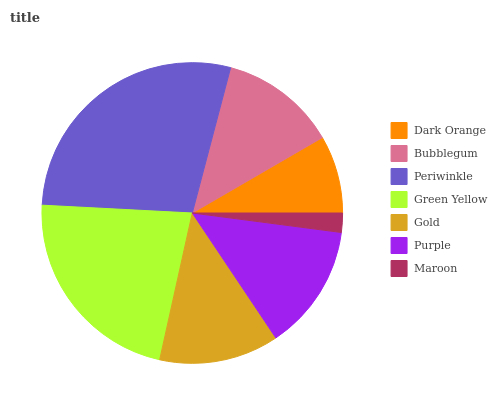Is Maroon the minimum?
Answer yes or no. Yes. Is Periwinkle the maximum?
Answer yes or no. Yes. Is Bubblegum the minimum?
Answer yes or no. No. Is Bubblegum the maximum?
Answer yes or no. No. Is Bubblegum greater than Dark Orange?
Answer yes or no. Yes. Is Dark Orange less than Bubblegum?
Answer yes or no. Yes. Is Dark Orange greater than Bubblegum?
Answer yes or no. No. Is Bubblegum less than Dark Orange?
Answer yes or no. No. Is Gold the high median?
Answer yes or no. Yes. Is Gold the low median?
Answer yes or no. Yes. Is Maroon the high median?
Answer yes or no. No. Is Dark Orange the low median?
Answer yes or no. No. 